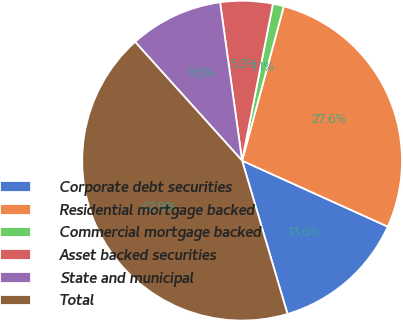<chart> <loc_0><loc_0><loc_500><loc_500><pie_chart><fcel>Corporate debt securities<fcel>Residential mortgage backed<fcel>Commercial mortgage backed<fcel>Asset backed securities<fcel>State and municipal<fcel>Total<nl><fcel>13.65%<fcel>27.57%<fcel>1.11%<fcel>5.29%<fcel>9.47%<fcel>42.91%<nl></chart> 